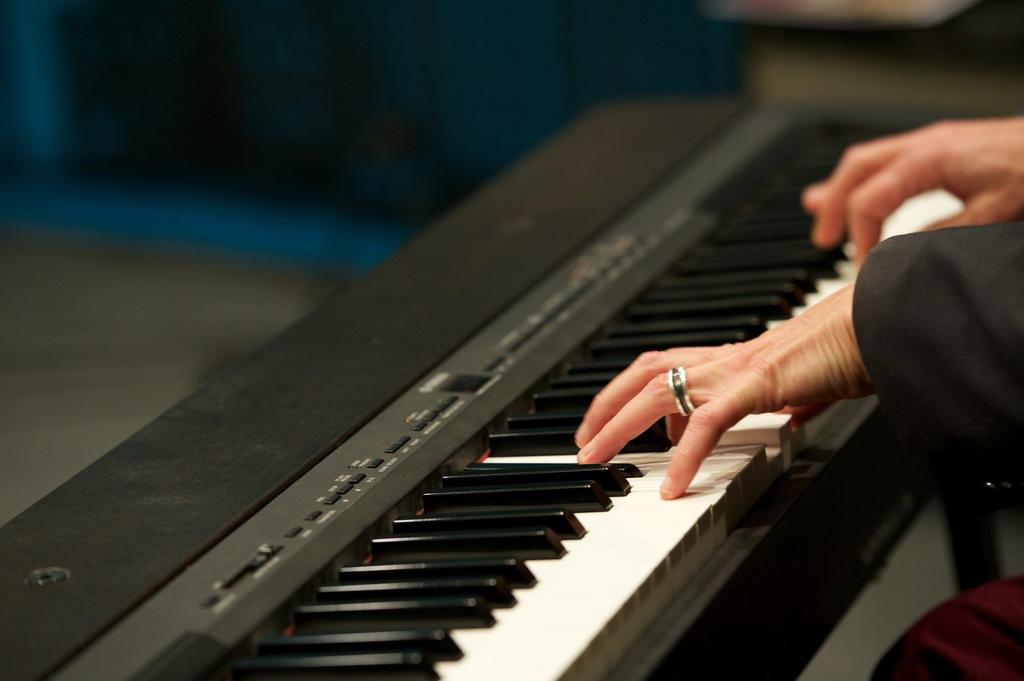What is the main subject of the image? There is a person in the image. What is the person doing in the image? The person is playing a piano. Can you describe the piano in the image? The piano has white and black keys. What type of notebook is the person using to write music in the image? There is no notebook present in the image, and the person is playing a piano, not writing music. 